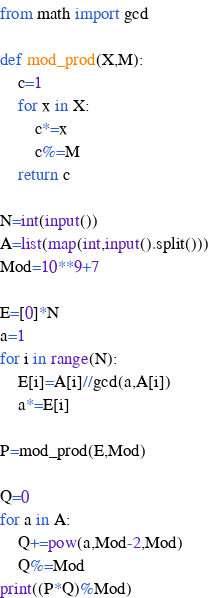<code> <loc_0><loc_0><loc_500><loc_500><_Python_>from math import gcd

def mod_prod(X,M):
    c=1
    for x in X:
        c*=x
        c%=M
    return c

N=int(input())
A=list(map(int,input().split()))
Mod=10**9+7

E=[0]*N
a=1
for i in range(N):
    E[i]=A[i]//gcd(a,A[i])
    a*=E[i]

P=mod_prod(E,Mod)

Q=0
for a in A:
    Q+=pow(a,Mod-2,Mod)
    Q%=Mod
print((P*Q)%Mod)</code> 